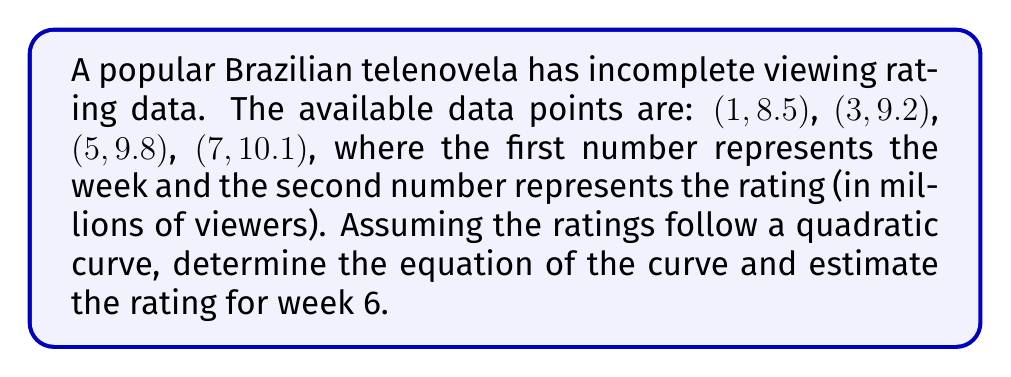Provide a solution to this math problem. To solve this inverse problem, we'll follow these steps:

1) Let's assume the quadratic equation has the form:
   $$ f(x) = ax^2 + bx + c $$
   where $x$ is the week number and $f(x)$ is the rating.

2) We need to find $a$, $b$, and $c$ using the given data points. We can set up a system of equations:

   $$ 8.5 = a(1)^2 + b(1) + c $$
   $$ 9.2 = a(3)^2 + b(3) + c $$
   $$ 9.8 = a(5)^2 + b(5) + c $$
   $$ 10.1 = a(7)^2 + b(7) + c $$

3) We can solve this system using matrix methods or by substitution. After solving, we get:

   $$ a \approx -0.0214 $$
   $$ b \approx 0.4071 $$
   $$ c \approx 8.1143 $$

4) Therefore, the equation of the curve is:
   $$ f(x) = -0.0214x^2 + 0.4071x + 8.1143 $$

5) To estimate the rating for week 6, we simply plug in $x = 6$:

   $$ f(6) = -0.0214(6)^2 + 0.4071(6) + 8.1143 $$
   $$ f(6) = -0.7704 + 2.4426 + 8.1143 $$
   $$ f(6) \approx 9.7865 $$
Answer: $f(x) = -0.0214x^2 + 0.4071x + 8.1143$; Week 6 rating: 9.79 million viewers 